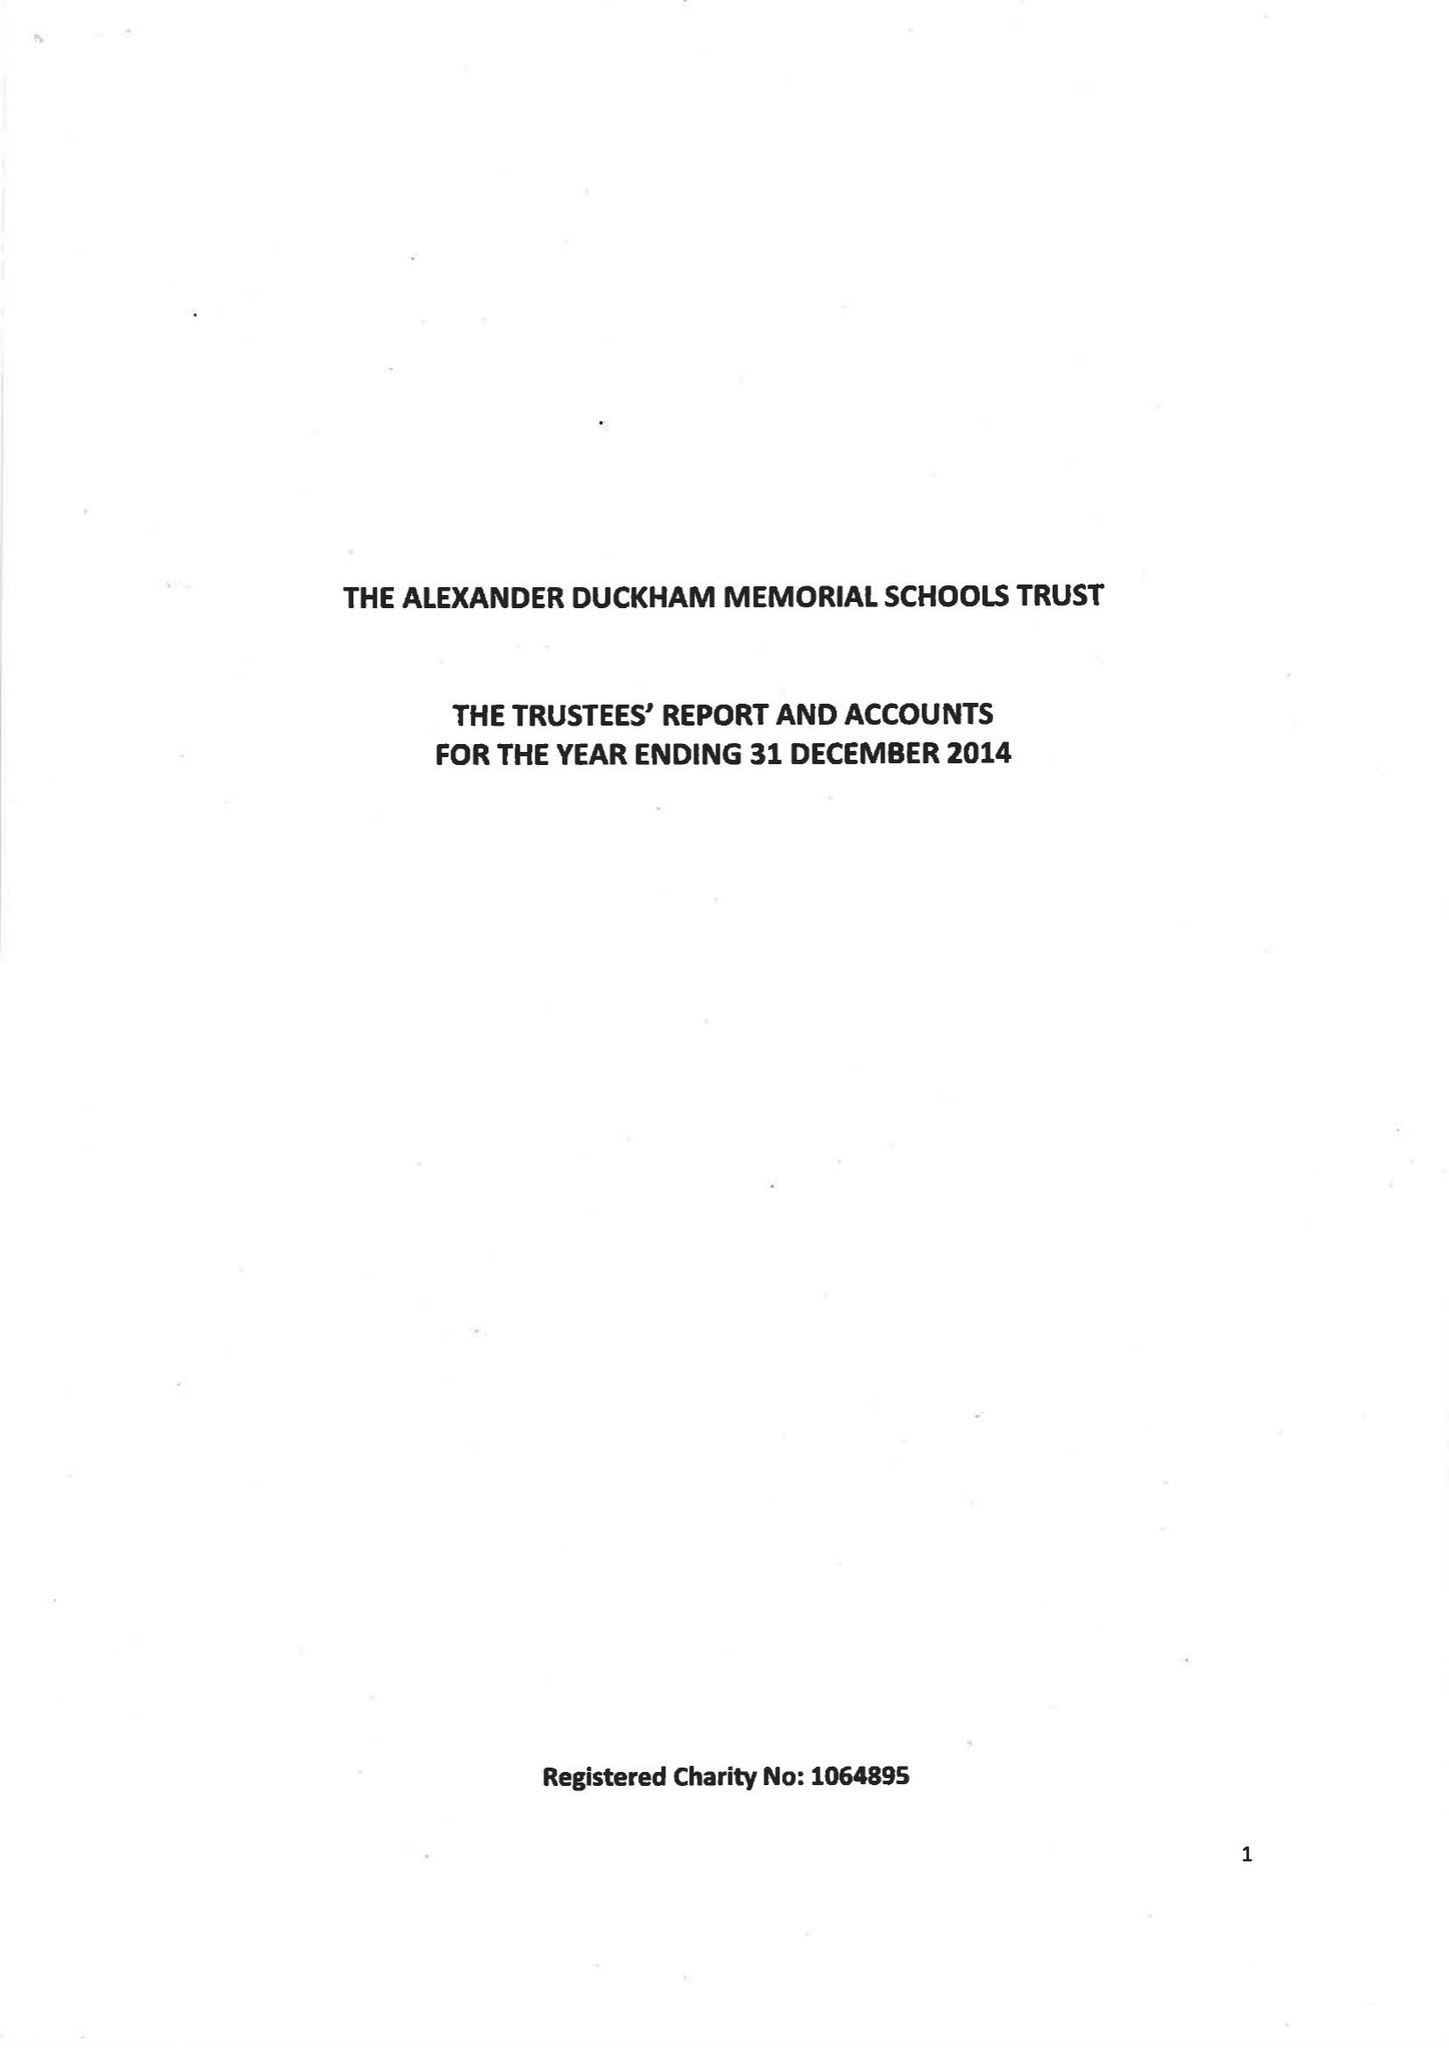What is the value for the charity_name?
Answer the question using a single word or phrase. The Alexander Duckham Memorial Schools Trust 